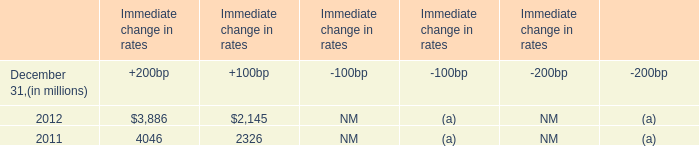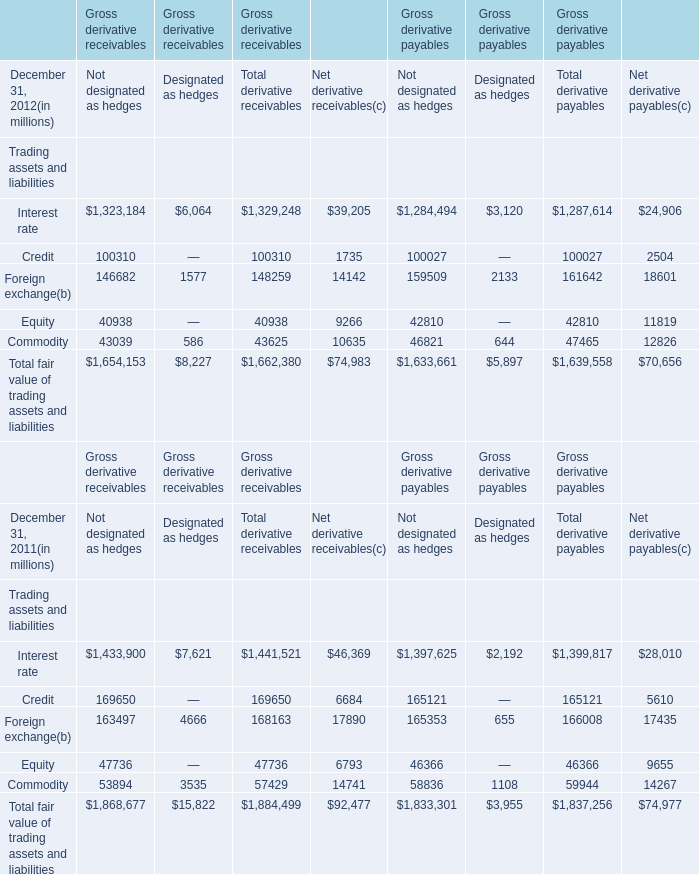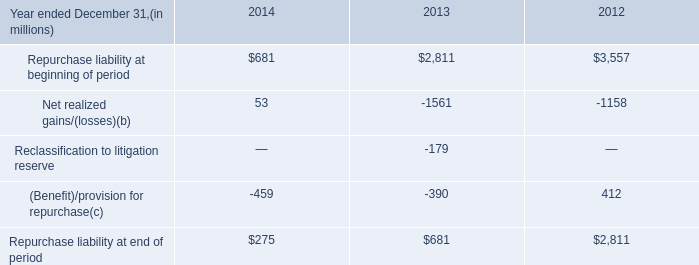What is the sum of Repurchase liability at beginning of period of 2012, and Foreign exchange of Gross derivative payables Net derivative payables ? 
Computations: (3557.0 + 18601.0)
Answer: 22158.0. 